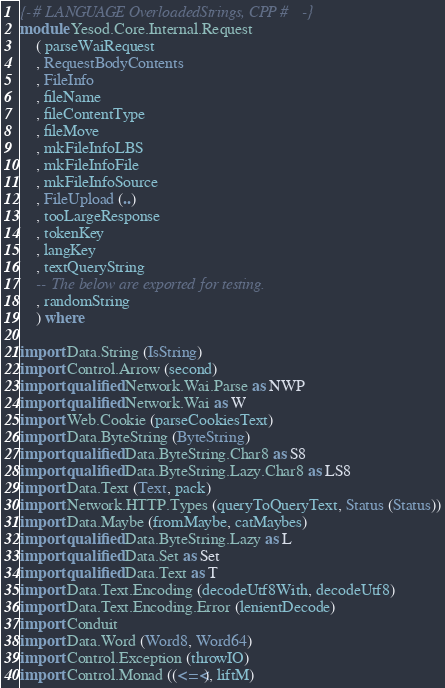<code> <loc_0><loc_0><loc_500><loc_500><_Haskell_>{-# LANGUAGE OverloadedStrings, CPP #-}
module Yesod.Core.Internal.Request
    ( parseWaiRequest
    , RequestBodyContents
    , FileInfo
    , fileName
    , fileContentType
    , fileMove
    , mkFileInfoLBS
    , mkFileInfoFile
    , mkFileInfoSource
    , FileUpload (..)
    , tooLargeResponse
    , tokenKey
    , langKey
    , textQueryString
    -- The below are exported for testing.
    , randomString
    ) where

import Data.String (IsString)
import Control.Arrow (second)
import qualified Network.Wai.Parse as NWP
import qualified Network.Wai as W
import Web.Cookie (parseCookiesText)
import Data.ByteString (ByteString)
import qualified Data.ByteString.Char8 as S8
import qualified Data.ByteString.Lazy.Char8 as LS8
import Data.Text (Text, pack)
import Network.HTTP.Types (queryToQueryText, Status (Status))
import Data.Maybe (fromMaybe, catMaybes)
import qualified Data.ByteString.Lazy as L
import qualified Data.Set as Set
import qualified Data.Text as T
import Data.Text.Encoding (decodeUtf8With, decodeUtf8)
import Data.Text.Encoding.Error (lenientDecode)
import Conduit
import Data.Word (Word8, Word64)
import Control.Exception (throwIO)
import Control.Monad ((<=<), liftM)</code> 